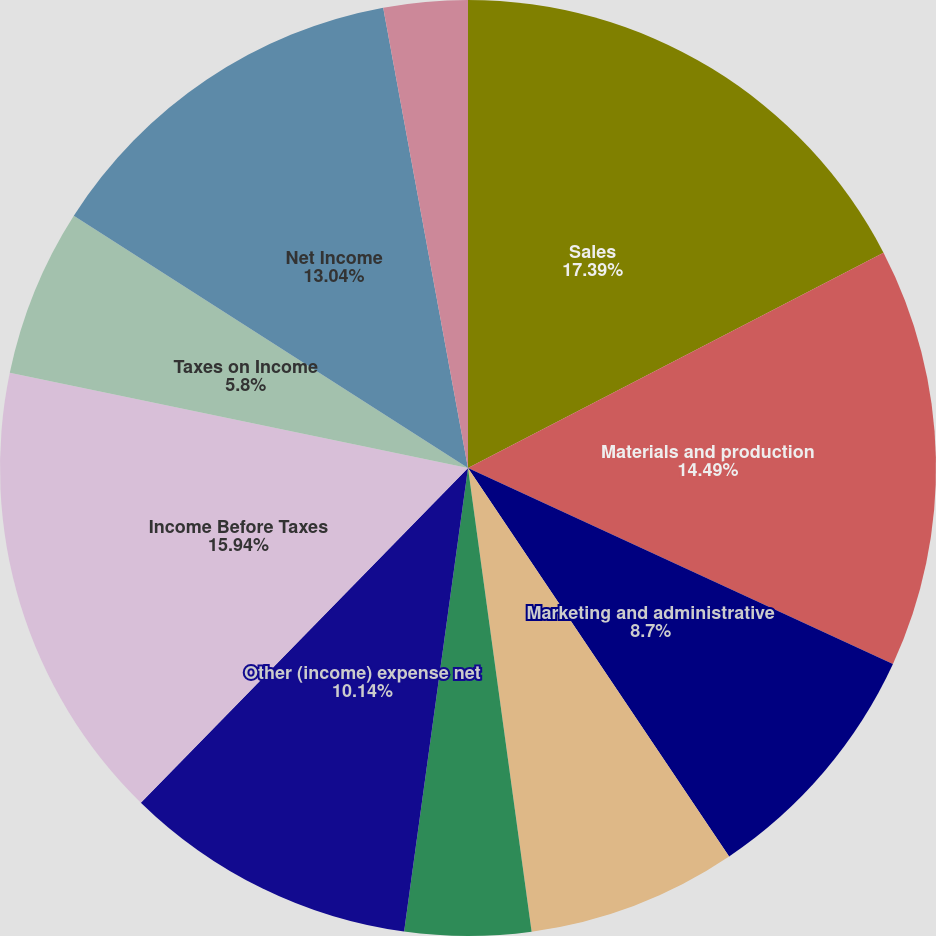<chart> <loc_0><loc_0><loc_500><loc_500><pie_chart><fcel>Sales<fcel>Materials and production<fcel>Marketing and administrative<fcel>Research and development<fcel>Restructuring costs<fcel>Other (income) expense net<fcel>Income Before Taxes<fcel>Taxes on Income<fcel>Net Income<fcel>Less Net Income Attributable<nl><fcel>17.39%<fcel>14.49%<fcel>8.7%<fcel>7.25%<fcel>4.35%<fcel>10.14%<fcel>15.94%<fcel>5.8%<fcel>13.04%<fcel>2.9%<nl></chart> 